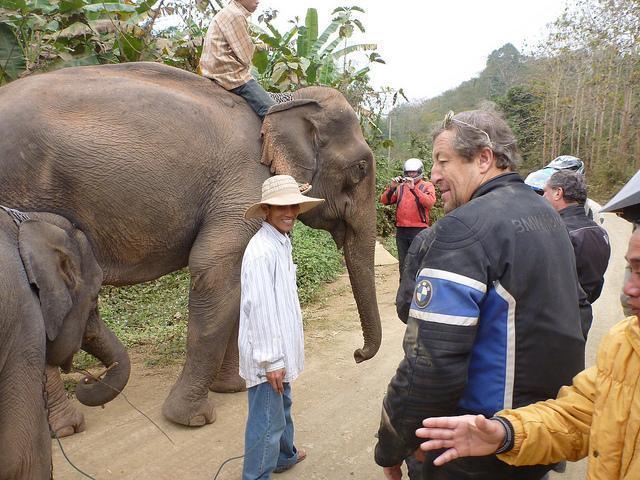How many elephants are in the photo?
Give a very brief answer. 2. How many people can you see?
Give a very brief answer. 6. 